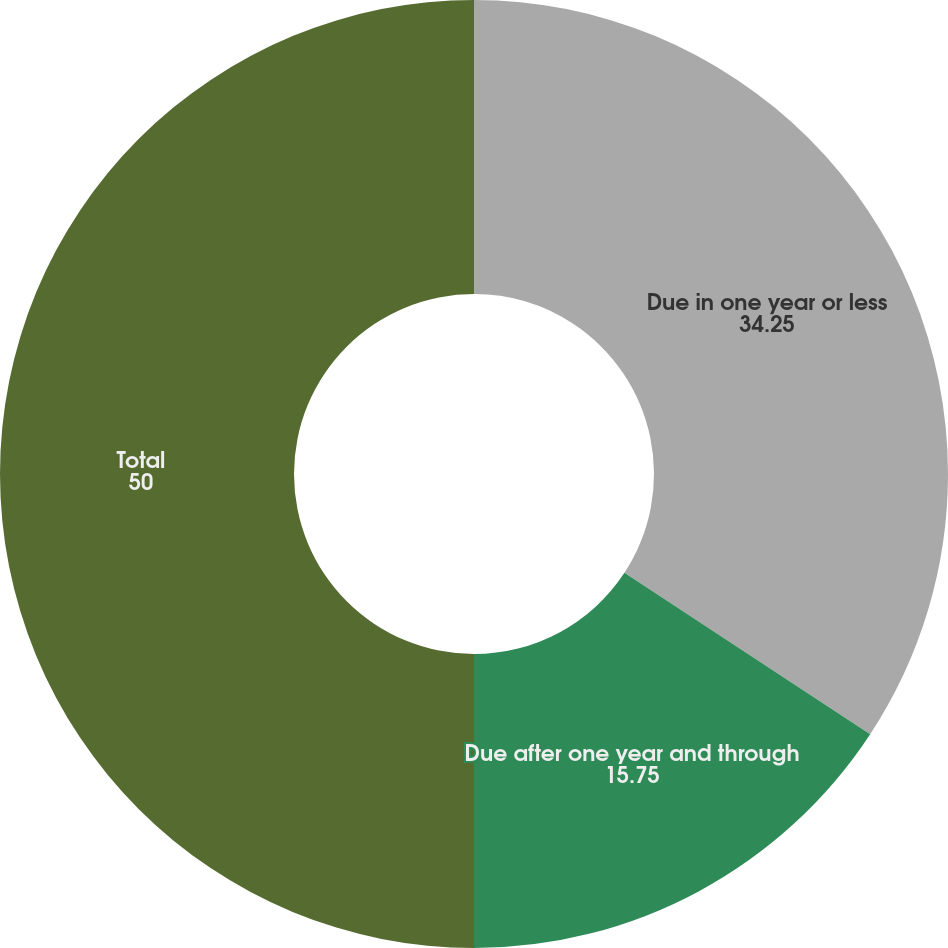Convert chart to OTSL. <chart><loc_0><loc_0><loc_500><loc_500><pie_chart><fcel>Due in one year or less<fcel>Due after one year and through<fcel>Total<nl><fcel>34.25%<fcel>15.75%<fcel>50.0%<nl></chart> 